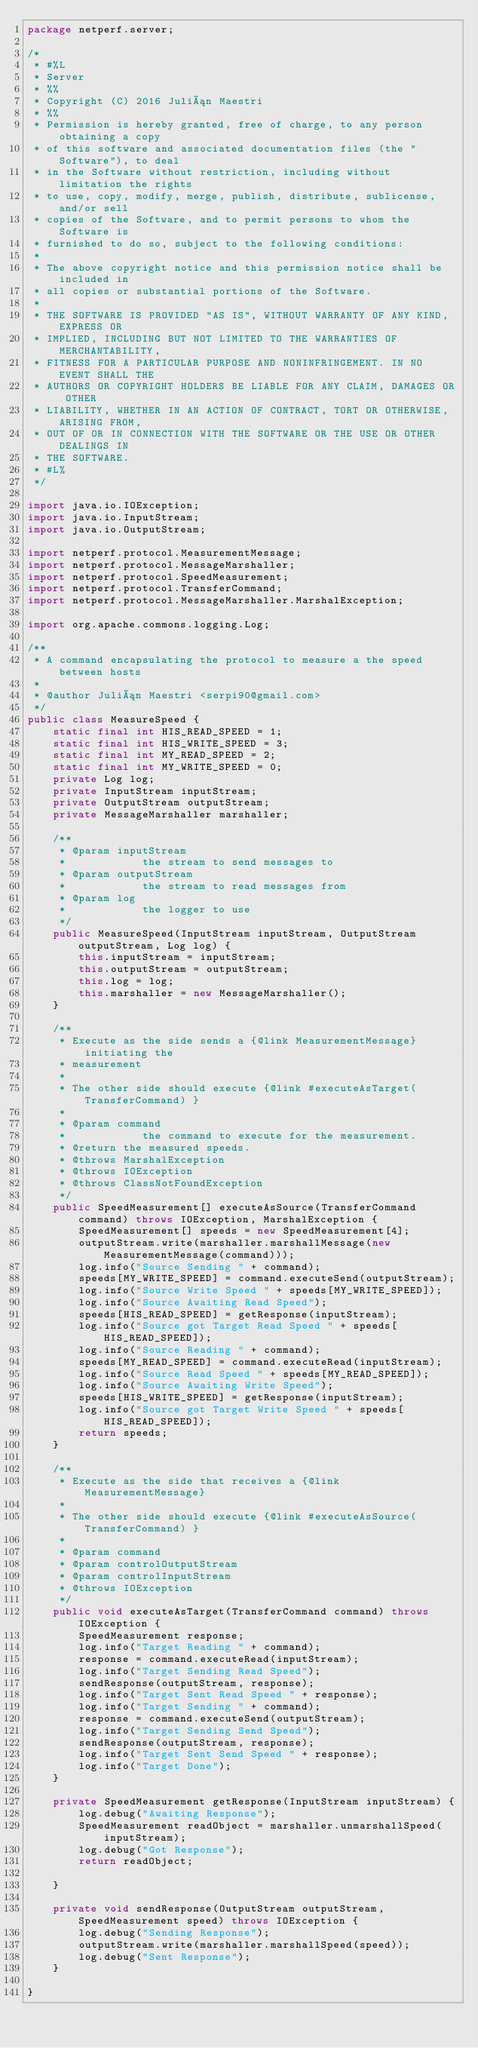Convert code to text. <code><loc_0><loc_0><loc_500><loc_500><_Java_>package netperf.server;

/*
 * #%L
 * Server
 * %%
 * Copyright (C) 2016 Julián Maestri
 * %%
 * Permission is hereby granted, free of charge, to any person obtaining a copy
 * of this software and associated documentation files (the "Software"), to deal
 * in the Software without restriction, including without limitation the rights
 * to use, copy, modify, merge, publish, distribute, sublicense, and/or sell
 * copies of the Software, and to permit persons to whom the Software is
 * furnished to do so, subject to the following conditions:
 * 
 * The above copyright notice and this permission notice shall be included in
 * all copies or substantial portions of the Software.
 * 
 * THE SOFTWARE IS PROVIDED "AS IS", WITHOUT WARRANTY OF ANY KIND, EXPRESS OR
 * IMPLIED, INCLUDING BUT NOT LIMITED TO THE WARRANTIES OF MERCHANTABILITY,
 * FITNESS FOR A PARTICULAR PURPOSE AND NONINFRINGEMENT. IN NO EVENT SHALL THE
 * AUTHORS OR COPYRIGHT HOLDERS BE LIABLE FOR ANY CLAIM, DAMAGES OR OTHER
 * LIABILITY, WHETHER IN AN ACTION OF CONTRACT, TORT OR OTHERWISE, ARISING FROM,
 * OUT OF OR IN CONNECTION WITH THE SOFTWARE OR THE USE OR OTHER DEALINGS IN
 * THE SOFTWARE.
 * #L%
 */

import java.io.IOException;
import java.io.InputStream;
import java.io.OutputStream;

import netperf.protocol.MeasurementMessage;
import netperf.protocol.MessageMarshaller;
import netperf.protocol.SpeedMeasurement;
import netperf.protocol.TransferCommand;
import netperf.protocol.MessageMarshaller.MarshalException;

import org.apache.commons.logging.Log;

/**
 * A command encapsulating the protocol to measure a the speed between hosts
 * 
 * @author Julián Maestri <serpi90@gmail.com>
 */
public class MeasureSpeed {
	static final int HIS_READ_SPEED = 1;
	static final int HIS_WRITE_SPEED = 3;
	static final int MY_READ_SPEED = 2;
	static final int MY_WRITE_SPEED = 0;
	private Log log;
	private InputStream inputStream;
	private OutputStream outputStream;
	private MessageMarshaller marshaller;

	/**
	 * @param inputStream
	 *            the stream to send messages to
	 * @param outputStream
	 *            the stream to read messages from
	 * @param log
	 *            the logger to use
	 */
	public MeasureSpeed(InputStream inputStream, OutputStream outputStream, Log log) {
		this.inputStream = inputStream;
		this.outputStream = outputStream;
		this.log = log;
		this.marshaller = new MessageMarshaller();
	}

	/**
	 * Execute as the side sends a {@link MeasurementMessage} initiating the
	 * measurement
	 * 
	 * The other side should execute {@link #executeAsTarget(TransferCommand) }
	 * 
	 * @param command
	 *            the command to execute for the measurement.
	 * @return the measured speeds.
	 * @throws MarshalException
	 * @throws IOException
	 * @throws ClassNotFoundException
	 */
	public SpeedMeasurement[] executeAsSource(TransferCommand command) throws IOException, MarshalException {
		SpeedMeasurement[] speeds = new SpeedMeasurement[4];
		outputStream.write(marshaller.marshallMessage(new MeasurementMessage(command)));
		log.info("Source Sending " + command);
		speeds[MY_WRITE_SPEED] = command.executeSend(outputStream);
		log.info("Source Write Speed " + speeds[MY_WRITE_SPEED]);
		log.info("Source Awaiting Read Speed");
		speeds[HIS_READ_SPEED] = getResponse(inputStream);
		log.info("Source got Target Read Speed " + speeds[HIS_READ_SPEED]);
		log.info("Source Reading " + command);
		speeds[MY_READ_SPEED] = command.executeRead(inputStream);
		log.info("Source Read Speed " + speeds[MY_READ_SPEED]);
		log.info("Source Awaiting Write Speed");
		speeds[HIS_WRITE_SPEED] = getResponse(inputStream);
		log.info("Source got Target Write Speed " + speeds[HIS_READ_SPEED]);
		return speeds;
	}

	/**
	 * Execute as the side that receives a {@link MeasurementMessage}
	 * 
	 * The other side should execute {@link #executeAsSource(TransferCommand) }
	 * 
	 * @param command
	 * @param controlOutputStream
	 * @param controlInputStream
	 * @throws IOException
	 */
	public void executeAsTarget(TransferCommand command) throws IOException {
		SpeedMeasurement response;
		log.info("Target Reading " + command);
		response = command.executeRead(inputStream);
		log.info("Target Sending Read Speed");
		sendResponse(outputStream, response);
		log.info("Target Sent Read Speed " + response);
		log.info("Target Sending " + command);
		response = command.executeSend(outputStream);
		log.info("Target Sending Send Speed");
		sendResponse(outputStream, response);
		log.info("Target Sent Send Speed " + response);
		log.info("Target Done");
	}

	private SpeedMeasurement getResponse(InputStream inputStream) {
		log.debug("Awaiting Response");
		SpeedMeasurement readObject = marshaller.unmarshallSpeed(inputStream);
		log.debug("Got Response");
		return readObject;

	}

	private void sendResponse(OutputStream outputStream, SpeedMeasurement speed) throws IOException {
		log.debug("Sending Response");
		outputStream.write(marshaller.marshallSpeed(speed));
		log.debug("Sent Response");
	}

}
</code> 